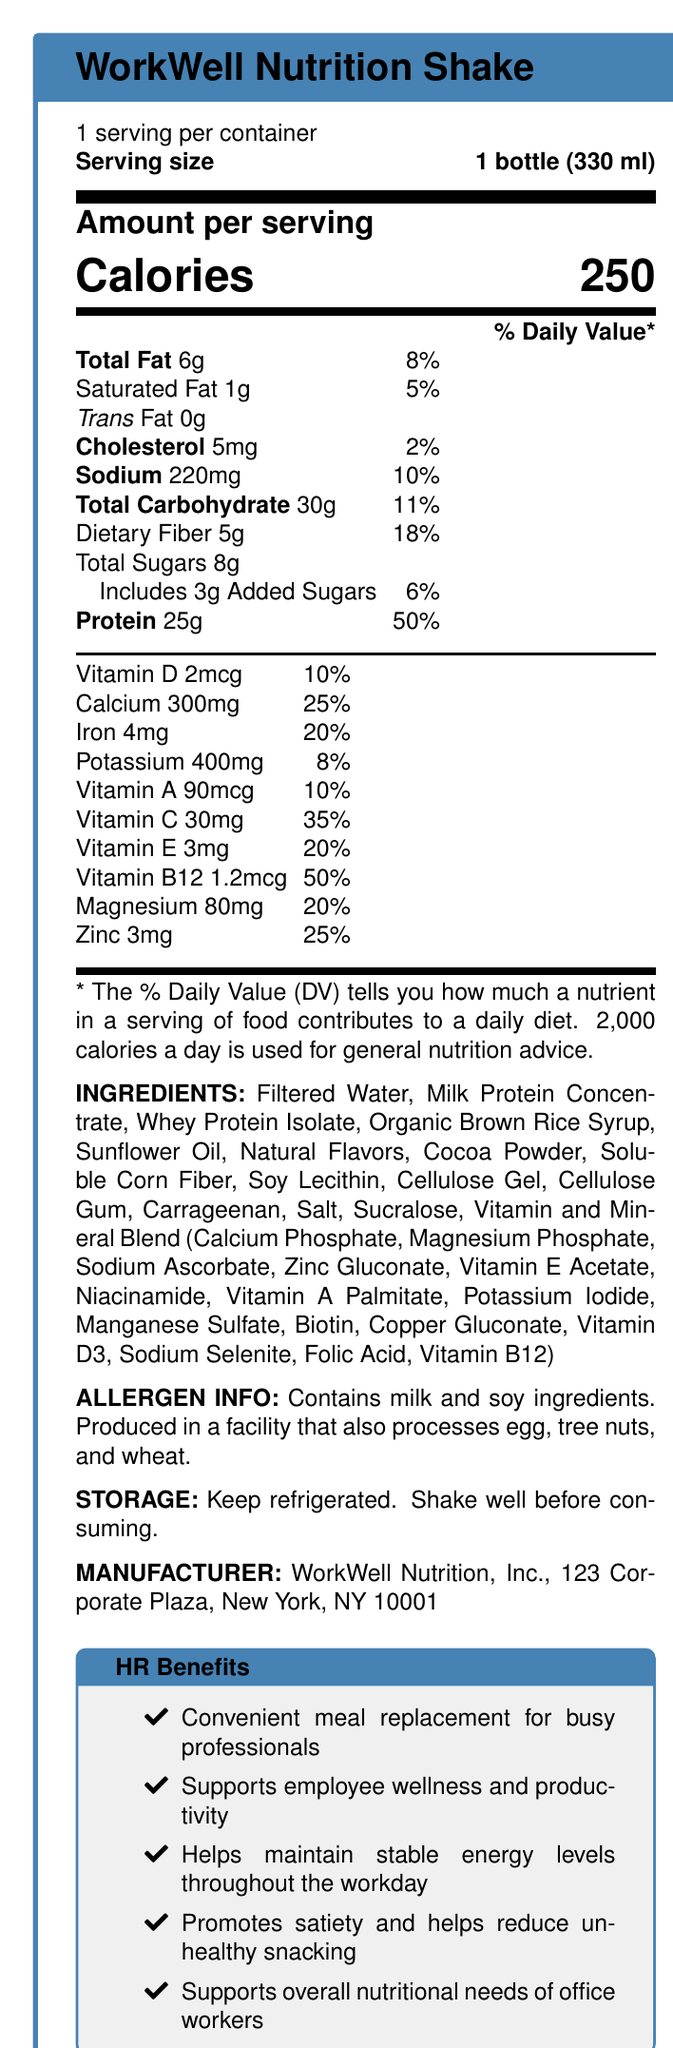what is the serving size of "WorkWell Nutrition Shake"? The document specifies under "Serving size" that the serving size is 1 bottle (330 ml).
Answer: 1 bottle (330 ml) how many calories are in one serving of "WorkWell Nutrition Shake"? The document states "Calories" as 250 under "Amount per serving".
Answer: 250 what is the protein content per serving, and what percentage of the daily value does it contribute? Under the "Amount per serving" section, it is listed as "Protein 25g" with a 50% daily value contribution.
Answer: 25g, 50% how much total fat does "WorkWell Nutrition Shake" contain per serving? The "Total Fat" per serving is listed as 6g in the document.
Answer: 6g what are the allergen ingredients mentioned in the document? The allergen information section states the product contains milk and soy ingredients.
Answer: milk and soy ingredients what are the storage instructions provided for the "WorkWell Nutrition Shake"? A. Store at room temperature B. Keep refrigerated C. Store in a cool, dry place D. Keep in the freezer The document specifies "Keep refrigerated" under the storage instructions.
Answer: B. Keep refrigerated what is the amount of added sugars in the shake? A. 1g B. 3g C. 5g D. 8g The document states that the shake includes 3g added sugars.
Answer: B. 3g does the product support cognitive function and energy levels? This is mentioned under the "additional claims" section of the document as one of the claims.
Answer: Yes what additional nutritional values are promoted by the "WorkWell Nutrition Shake"? These additional claims are listed under the "additional_claims" in the document.
Answer: Excellent source of protein, Good source of fiber, 25 essential vitamins and minerals, No artificial colors, Supports cognitive function and energy levels summarize the document. The summary encapsulates the main points: the product details, nutritional values, health benefits, ingredients, storage instructions, and allergen info.
Answer: The "WorkWell Nutrition Shake" is a meal replacement designed for office workers, providing 250 calories per serving. It contains 25g of protein (50% DV) and is enriched with vitamins and minerals, including Vitamin D, Calcium, Iron, and more. The shake supports employee wellness, cognitive function, and maintains energy levels. Ingredients are mainly water, proteins, and natural flavors, with allergen warnings for milk and soy. It requires refrigeration and is advantageous for busy professionals. what is the daily value percentage of dietary fiber in one serving of the shake? The document lists "Dietary Fiber 5g" with an 18% daily value.
Answer: 18% how many essential vitamins and minerals does the shake contain? The document claims "25 essential vitamins and minerals" in the additional claims, but it does not specify or list out all of them clearly to confirm the total count.
Answer: Cannot be determined what are some of the hr benefits of the "WorkWell Nutrition Shake"? The HR benefits are listed under the "HR Benefits" section in the document.
Answer: Convenient meal replacement for busy professionals, Supports employee wellness and productivity, Helps maintain stable energy levels throughout the workday, Promotes satiety and helps reduce unhealthy snacking, Supports overall nutritional needs of office workers how many milligrams of calcium are in one serving of the shake? The document states "Calcium 300mg" in the vitamin and mineral content list.
Answer: 300mg 